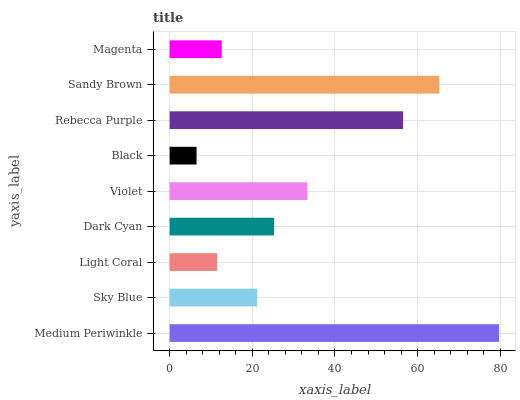Is Black the minimum?
Answer yes or no. Yes. Is Medium Periwinkle the maximum?
Answer yes or no. Yes. Is Sky Blue the minimum?
Answer yes or no. No. Is Sky Blue the maximum?
Answer yes or no. No. Is Medium Periwinkle greater than Sky Blue?
Answer yes or no. Yes. Is Sky Blue less than Medium Periwinkle?
Answer yes or no. Yes. Is Sky Blue greater than Medium Periwinkle?
Answer yes or no. No. Is Medium Periwinkle less than Sky Blue?
Answer yes or no. No. Is Dark Cyan the high median?
Answer yes or no. Yes. Is Dark Cyan the low median?
Answer yes or no. Yes. Is Light Coral the high median?
Answer yes or no. No. Is Sky Blue the low median?
Answer yes or no. No. 